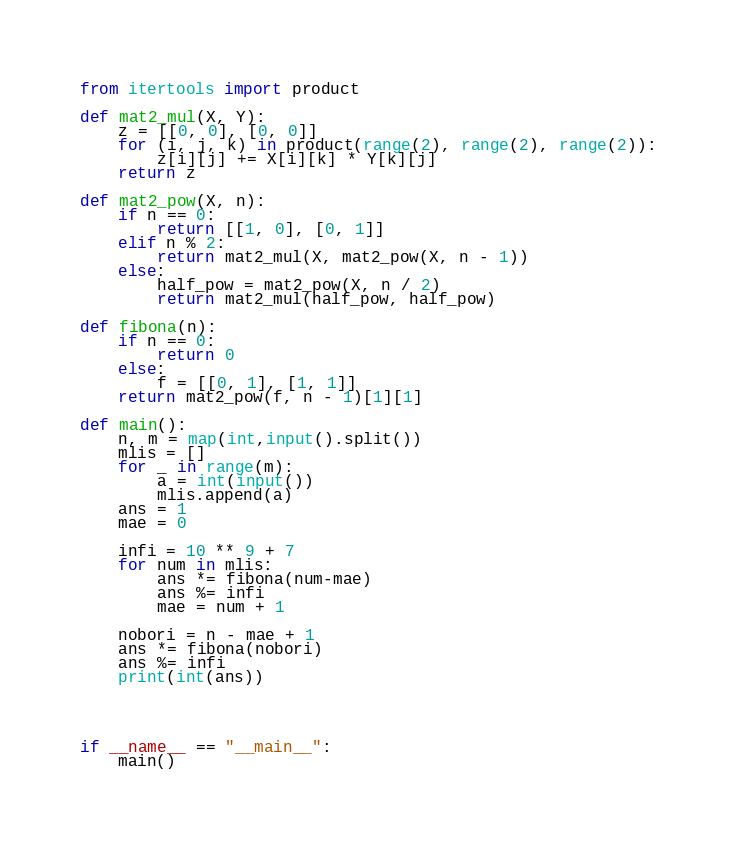Convert code to text. <code><loc_0><loc_0><loc_500><loc_500><_Python_>from itertools import product

def mat2_mul(X, Y):
	z = [[0, 0], [0, 0]]
	for (i, j, k) in product(range(2), range(2), range(2)):
		z[i][j] += X[i][k] * Y[k][j]
	return z

def mat2_pow(X, n):
	if n == 0:
		return [[1, 0], [0, 1]]
	elif n % 2:
		return mat2_mul(X, mat2_pow(X, n - 1))
	else:
		half_pow = mat2_pow(X, n / 2)
		return mat2_mul(half_pow, half_pow)

def fibona(n):
	if n == 0:
		return 0
	else:
		f = [[0, 1], [1, 1]]
	return mat2_pow(f, n - 1)[1][1]

def main():
    n, m = map(int,input().split())
    mlis = []
    for _ in range(m):
        a = int(input())
        mlis.append(a)
    ans = 1
    mae = 0

    infi = 10 ** 9 + 7
    for num in mlis:
        ans *= fibona(num-mae)
        ans %= infi
        mae = num + 1

    nobori = n - mae + 1
    ans *= fibona(nobori) 
    ans %= infi
    print(int(ans))
    



if __name__ == "__main__":
    main()</code> 